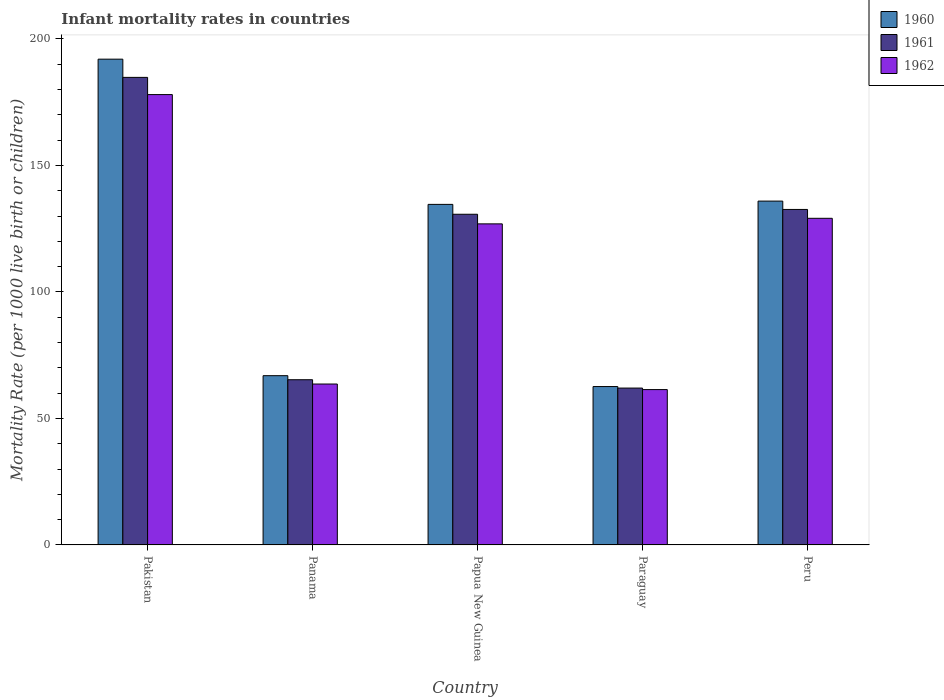How many different coloured bars are there?
Provide a succinct answer. 3. How many groups of bars are there?
Your answer should be very brief. 5. Are the number of bars per tick equal to the number of legend labels?
Your answer should be compact. Yes. Are the number of bars on each tick of the X-axis equal?
Keep it short and to the point. Yes. What is the label of the 3rd group of bars from the left?
Give a very brief answer. Papua New Guinea. What is the infant mortality rate in 1962 in Paraguay?
Your response must be concise. 61.4. Across all countries, what is the maximum infant mortality rate in 1962?
Your response must be concise. 178. Across all countries, what is the minimum infant mortality rate in 1960?
Make the answer very short. 62.6. In which country was the infant mortality rate in 1962 minimum?
Ensure brevity in your answer.  Paraguay. What is the total infant mortality rate in 1961 in the graph?
Offer a terse response. 575.4. What is the difference between the infant mortality rate in 1962 in Pakistan and that in Peru?
Your answer should be compact. 48.9. What is the difference between the infant mortality rate in 1961 in Paraguay and the infant mortality rate in 1962 in Pakistan?
Offer a very short reply. -116. What is the average infant mortality rate in 1962 per country?
Your response must be concise. 111.8. What is the difference between the infant mortality rate of/in 1960 and infant mortality rate of/in 1961 in Pakistan?
Give a very brief answer. 7.2. What is the ratio of the infant mortality rate in 1961 in Papua New Guinea to that in Paraguay?
Your response must be concise. 2.11. Is the infant mortality rate in 1962 in Panama less than that in Papua New Guinea?
Provide a succinct answer. Yes. What is the difference between the highest and the second highest infant mortality rate in 1961?
Your answer should be compact. 54.1. What is the difference between the highest and the lowest infant mortality rate in 1962?
Your answer should be very brief. 116.6. Is the sum of the infant mortality rate in 1961 in Panama and Papua New Guinea greater than the maximum infant mortality rate in 1960 across all countries?
Your answer should be compact. Yes. Does the graph contain grids?
Provide a succinct answer. No. Where does the legend appear in the graph?
Offer a very short reply. Top right. How many legend labels are there?
Make the answer very short. 3. How are the legend labels stacked?
Your response must be concise. Vertical. What is the title of the graph?
Offer a terse response. Infant mortality rates in countries. What is the label or title of the Y-axis?
Offer a very short reply. Mortality Rate (per 1000 live birth or children). What is the Mortality Rate (per 1000 live birth or children) in 1960 in Pakistan?
Offer a very short reply. 192. What is the Mortality Rate (per 1000 live birth or children) in 1961 in Pakistan?
Ensure brevity in your answer.  184.8. What is the Mortality Rate (per 1000 live birth or children) of 1962 in Pakistan?
Offer a very short reply. 178. What is the Mortality Rate (per 1000 live birth or children) in 1960 in Panama?
Your answer should be very brief. 66.9. What is the Mortality Rate (per 1000 live birth or children) of 1961 in Panama?
Provide a short and direct response. 65.3. What is the Mortality Rate (per 1000 live birth or children) of 1962 in Panama?
Give a very brief answer. 63.6. What is the Mortality Rate (per 1000 live birth or children) in 1960 in Papua New Guinea?
Your answer should be very brief. 134.6. What is the Mortality Rate (per 1000 live birth or children) in 1961 in Papua New Guinea?
Your response must be concise. 130.7. What is the Mortality Rate (per 1000 live birth or children) in 1962 in Papua New Guinea?
Keep it short and to the point. 126.9. What is the Mortality Rate (per 1000 live birth or children) in 1960 in Paraguay?
Ensure brevity in your answer.  62.6. What is the Mortality Rate (per 1000 live birth or children) in 1961 in Paraguay?
Your response must be concise. 62. What is the Mortality Rate (per 1000 live birth or children) of 1962 in Paraguay?
Offer a terse response. 61.4. What is the Mortality Rate (per 1000 live birth or children) of 1960 in Peru?
Offer a very short reply. 135.9. What is the Mortality Rate (per 1000 live birth or children) of 1961 in Peru?
Provide a succinct answer. 132.6. What is the Mortality Rate (per 1000 live birth or children) in 1962 in Peru?
Your answer should be compact. 129.1. Across all countries, what is the maximum Mortality Rate (per 1000 live birth or children) in 1960?
Make the answer very short. 192. Across all countries, what is the maximum Mortality Rate (per 1000 live birth or children) in 1961?
Ensure brevity in your answer.  184.8. Across all countries, what is the maximum Mortality Rate (per 1000 live birth or children) of 1962?
Keep it short and to the point. 178. Across all countries, what is the minimum Mortality Rate (per 1000 live birth or children) of 1960?
Your response must be concise. 62.6. Across all countries, what is the minimum Mortality Rate (per 1000 live birth or children) of 1961?
Your answer should be compact. 62. Across all countries, what is the minimum Mortality Rate (per 1000 live birth or children) in 1962?
Offer a terse response. 61.4. What is the total Mortality Rate (per 1000 live birth or children) in 1960 in the graph?
Ensure brevity in your answer.  592. What is the total Mortality Rate (per 1000 live birth or children) of 1961 in the graph?
Offer a very short reply. 575.4. What is the total Mortality Rate (per 1000 live birth or children) of 1962 in the graph?
Offer a terse response. 559. What is the difference between the Mortality Rate (per 1000 live birth or children) of 1960 in Pakistan and that in Panama?
Offer a very short reply. 125.1. What is the difference between the Mortality Rate (per 1000 live birth or children) in 1961 in Pakistan and that in Panama?
Ensure brevity in your answer.  119.5. What is the difference between the Mortality Rate (per 1000 live birth or children) of 1962 in Pakistan and that in Panama?
Your answer should be compact. 114.4. What is the difference between the Mortality Rate (per 1000 live birth or children) of 1960 in Pakistan and that in Papua New Guinea?
Make the answer very short. 57.4. What is the difference between the Mortality Rate (per 1000 live birth or children) in 1961 in Pakistan and that in Papua New Guinea?
Your answer should be very brief. 54.1. What is the difference between the Mortality Rate (per 1000 live birth or children) of 1962 in Pakistan and that in Papua New Guinea?
Offer a terse response. 51.1. What is the difference between the Mortality Rate (per 1000 live birth or children) of 1960 in Pakistan and that in Paraguay?
Ensure brevity in your answer.  129.4. What is the difference between the Mortality Rate (per 1000 live birth or children) in 1961 in Pakistan and that in Paraguay?
Keep it short and to the point. 122.8. What is the difference between the Mortality Rate (per 1000 live birth or children) in 1962 in Pakistan and that in Paraguay?
Your answer should be very brief. 116.6. What is the difference between the Mortality Rate (per 1000 live birth or children) of 1960 in Pakistan and that in Peru?
Give a very brief answer. 56.1. What is the difference between the Mortality Rate (per 1000 live birth or children) of 1961 in Pakistan and that in Peru?
Your answer should be very brief. 52.2. What is the difference between the Mortality Rate (per 1000 live birth or children) in 1962 in Pakistan and that in Peru?
Ensure brevity in your answer.  48.9. What is the difference between the Mortality Rate (per 1000 live birth or children) in 1960 in Panama and that in Papua New Guinea?
Offer a terse response. -67.7. What is the difference between the Mortality Rate (per 1000 live birth or children) in 1961 in Panama and that in Papua New Guinea?
Keep it short and to the point. -65.4. What is the difference between the Mortality Rate (per 1000 live birth or children) in 1962 in Panama and that in Papua New Guinea?
Provide a short and direct response. -63.3. What is the difference between the Mortality Rate (per 1000 live birth or children) in 1960 in Panama and that in Paraguay?
Your response must be concise. 4.3. What is the difference between the Mortality Rate (per 1000 live birth or children) of 1960 in Panama and that in Peru?
Ensure brevity in your answer.  -69. What is the difference between the Mortality Rate (per 1000 live birth or children) of 1961 in Panama and that in Peru?
Keep it short and to the point. -67.3. What is the difference between the Mortality Rate (per 1000 live birth or children) of 1962 in Panama and that in Peru?
Offer a very short reply. -65.5. What is the difference between the Mortality Rate (per 1000 live birth or children) of 1960 in Papua New Guinea and that in Paraguay?
Offer a terse response. 72. What is the difference between the Mortality Rate (per 1000 live birth or children) in 1961 in Papua New Guinea and that in Paraguay?
Make the answer very short. 68.7. What is the difference between the Mortality Rate (per 1000 live birth or children) of 1962 in Papua New Guinea and that in Paraguay?
Give a very brief answer. 65.5. What is the difference between the Mortality Rate (per 1000 live birth or children) of 1962 in Papua New Guinea and that in Peru?
Keep it short and to the point. -2.2. What is the difference between the Mortality Rate (per 1000 live birth or children) of 1960 in Paraguay and that in Peru?
Provide a short and direct response. -73.3. What is the difference between the Mortality Rate (per 1000 live birth or children) of 1961 in Paraguay and that in Peru?
Your response must be concise. -70.6. What is the difference between the Mortality Rate (per 1000 live birth or children) in 1962 in Paraguay and that in Peru?
Give a very brief answer. -67.7. What is the difference between the Mortality Rate (per 1000 live birth or children) in 1960 in Pakistan and the Mortality Rate (per 1000 live birth or children) in 1961 in Panama?
Provide a succinct answer. 126.7. What is the difference between the Mortality Rate (per 1000 live birth or children) of 1960 in Pakistan and the Mortality Rate (per 1000 live birth or children) of 1962 in Panama?
Make the answer very short. 128.4. What is the difference between the Mortality Rate (per 1000 live birth or children) of 1961 in Pakistan and the Mortality Rate (per 1000 live birth or children) of 1962 in Panama?
Your response must be concise. 121.2. What is the difference between the Mortality Rate (per 1000 live birth or children) of 1960 in Pakistan and the Mortality Rate (per 1000 live birth or children) of 1961 in Papua New Guinea?
Make the answer very short. 61.3. What is the difference between the Mortality Rate (per 1000 live birth or children) of 1960 in Pakistan and the Mortality Rate (per 1000 live birth or children) of 1962 in Papua New Guinea?
Give a very brief answer. 65.1. What is the difference between the Mortality Rate (per 1000 live birth or children) in 1961 in Pakistan and the Mortality Rate (per 1000 live birth or children) in 1962 in Papua New Guinea?
Your answer should be compact. 57.9. What is the difference between the Mortality Rate (per 1000 live birth or children) in 1960 in Pakistan and the Mortality Rate (per 1000 live birth or children) in 1961 in Paraguay?
Your answer should be very brief. 130. What is the difference between the Mortality Rate (per 1000 live birth or children) in 1960 in Pakistan and the Mortality Rate (per 1000 live birth or children) in 1962 in Paraguay?
Provide a succinct answer. 130.6. What is the difference between the Mortality Rate (per 1000 live birth or children) of 1961 in Pakistan and the Mortality Rate (per 1000 live birth or children) of 1962 in Paraguay?
Your answer should be very brief. 123.4. What is the difference between the Mortality Rate (per 1000 live birth or children) of 1960 in Pakistan and the Mortality Rate (per 1000 live birth or children) of 1961 in Peru?
Provide a succinct answer. 59.4. What is the difference between the Mortality Rate (per 1000 live birth or children) in 1960 in Pakistan and the Mortality Rate (per 1000 live birth or children) in 1962 in Peru?
Your response must be concise. 62.9. What is the difference between the Mortality Rate (per 1000 live birth or children) of 1961 in Pakistan and the Mortality Rate (per 1000 live birth or children) of 1962 in Peru?
Provide a short and direct response. 55.7. What is the difference between the Mortality Rate (per 1000 live birth or children) in 1960 in Panama and the Mortality Rate (per 1000 live birth or children) in 1961 in Papua New Guinea?
Ensure brevity in your answer.  -63.8. What is the difference between the Mortality Rate (per 1000 live birth or children) in 1960 in Panama and the Mortality Rate (per 1000 live birth or children) in 1962 in Papua New Guinea?
Offer a terse response. -60. What is the difference between the Mortality Rate (per 1000 live birth or children) in 1961 in Panama and the Mortality Rate (per 1000 live birth or children) in 1962 in Papua New Guinea?
Make the answer very short. -61.6. What is the difference between the Mortality Rate (per 1000 live birth or children) in 1961 in Panama and the Mortality Rate (per 1000 live birth or children) in 1962 in Paraguay?
Make the answer very short. 3.9. What is the difference between the Mortality Rate (per 1000 live birth or children) in 1960 in Panama and the Mortality Rate (per 1000 live birth or children) in 1961 in Peru?
Your answer should be compact. -65.7. What is the difference between the Mortality Rate (per 1000 live birth or children) of 1960 in Panama and the Mortality Rate (per 1000 live birth or children) of 1962 in Peru?
Your answer should be compact. -62.2. What is the difference between the Mortality Rate (per 1000 live birth or children) of 1961 in Panama and the Mortality Rate (per 1000 live birth or children) of 1962 in Peru?
Your answer should be very brief. -63.8. What is the difference between the Mortality Rate (per 1000 live birth or children) of 1960 in Papua New Guinea and the Mortality Rate (per 1000 live birth or children) of 1961 in Paraguay?
Offer a very short reply. 72.6. What is the difference between the Mortality Rate (per 1000 live birth or children) in 1960 in Papua New Guinea and the Mortality Rate (per 1000 live birth or children) in 1962 in Paraguay?
Offer a terse response. 73.2. What is the difference between the Mortality Rate (per 1000 live birth or children) of 1961 in Papua New Guinea and the Mortality Rate (per 1000 live birth or children) of 1962 in Paraguay?
Your response must be concise. 69.3. What is the difference between the Mortality Rate (per 1000 live birth or children) in 1960 in Papua New Guinea and the Mortality Rate (per 1000 live birth or children) in 1961 in Peru?
Your answer should be compact. 2. What is the difference between the Mortality Rate (per 1000 live birth or children) of 1961 in Papua New Guinea and the Mortality Rate (per 1000 live birth or children) of 1962 in Peru?
Ensure brevity in your answer.  1.6. What is the difference between the Mortality Rate (per 1000 live birth or children) in 1960 in Paraguay and the Mortality Rate (per 1000 live birth or children) in 1961 in Peru?
Make the answer very short. -70. What is the difference between the Mortality Rate (per 1000 live birth or children) in 1960 in Paraguay and the Mortality Rate (per 1000 live birth or children) in 1962 in Peru?
Provide a short and direct response. -66.5. What is the difference between the Mortality Rate (per 1000 live birth or children) of 1961 in Paraguay and the Mortality Rate (per 1000 live birth or children) of 1962 in Peru?
Offer a terse response. -67.1. What is the average Mortality Rate (per 1000 live birth or children) of 1960 per country?
Your answer should be very brief. 118.4. What is the average Mortality Rate (per 1000 live birth or children) of 1961 per country?
Provide a short and direct response. 115.08. What is the average Mortality Rate (per 1000 live birth or children) in 1962 per country?
Make the answer very short. 111.8. What is the difference between the Mortality Rate (per 1000 live birth or children) in 1960 and Mortality Rate (per 1000 live birth or children) in 1962 in Papua New Guinea?
Provide a succinct answer. 7.7. What is the difference between the Mortality Rate (per 1000 live birth or children) in 1961 and Mortality Rate (per 1000 live birth or children) in 1962 in Papua New Guinea?
Give a very brief answer. 3.8. What is the difference between the Mortality Rate (per 1000 live birth or children) of 1960 and Mortality Rate (per 1000 live birth or children) of 1962 in Peru?
Provide a short and direct response. 6.8. What is the ratio of the Mortality Rate (per 1000 live birth or children) of 1960 in Pakistan to that in Panama?
Offer a terse response. 2.87. What is the ratio of the Mortality Rate (per 1000 live birth or children) of 1961 in Pakistan to that in Panama?
Give a very brief answer. 2.83. What is the ratio of the Mortality Rate (per 1000 live birth or children) of 1962 in Pakistan to that in Panama?
Provide a short and direct response. 2.8. What is the ratio of the Mortality Rate (per 1000 live birth or children) in 1960 in Pakistan to that in Papua New Guinea?
Keep it short and to the point. 1.43. What is the ratio of the Mortality Rate (per 1000 live birth or children) of 1961 in Pakistan to that in Papua New Guinea?
Offer a terse response. 1.41. What is the ratio of the Mortality Rate (per 1000 live birth or children) of 1962 in Pakistan to that in Papua New Guinea?
Your response must be concise. 1.4. What is the ratio of the Mortality Rate (per 1000 live birth or children) of 1960 in Pakistan to that in Paraguay?
Ensure brevity in your answer.  3.07. What is the ratio of the Mortality Rate (per 1000 live birth or children) of 1961 in Pakistan to that in Paraguay?
Offer a terse response. 2.98. What is the ratio of the Mortality Rate (per 1000 live birth or children) of 1962 in Pakistan to that in Paraguay?
Provide a succinct answer. 2.9. What is the ratio of the Mortality Rate (per 1000 live birth or children) in 1960 in Pakistan to that in Peru?
Your answer should be very brief. 1.41. What is the ratio of the Mortality Rate (per 1000 live birth or children) of 1961 in Pakistan to that in Peru?
Offer a very short reply. 1.39. What is the ratio of the Mortality Rate (per 1000 live birth or children) of 1962 in Pakistan to that in Peru?
Your answer should be compact. 1.38. What is the ratio of the Mortality Rate (per 1000 live birth or children) of 1960 in Panama to that in Papua New Guinea?
Provide a short and direct response. 0.5. What is the ratio of the Mortality Rate (per 1000 live birth or children) in 1961 in Panama to that in Papua New Guinea?
Your response must be concise. 0.5. What is the ratio of the Mortality Rate (per 1000 live birth or children) in 1962 in Panama to that in Papua New Guinea?
Your response must be concise. 0.5. What is the ratio of the Mortality Rate (per 1000 live birth or children) in 1960 in Panama to that in Paraguay?
Provide a succinct answer. 1.07. What is the ratio of the Mortality Rate (per 1000 live birth or children) of 1961 in Panama to that in Paraguay?
Ensure brevity in your answer.  1.05. What is the ratio of the Mortality Rate (per 1000 live birth or children) in 1962 in Panama to that in Paraguay?
Offer a terse response. 1.04. What is the ratio of the Mortality Rate (per 1000 live birth or children) in 1960 in Panama to that in Peru?
Your answer should be compact. 0.49. What is the ratio of the Mortality Rate (per 1000 live birth or children) of 1961 in Panama to that in Peru?
Offer a very short reply. 0.49. What is the ratio of the Mortality Rate (per 1000 live birth or children) of 1962 in Panama to that in Peru?
Provide a short and direct response. 0.49. What is the ratio of the Mortality Rate (per 1000 live birth or children) of 1960 in Papua New Guinea to that in Paraguay?
Give a very brief answer. 2.15. What is the ratio of the Mortality Rate (per 1000 live birth or children) of 1961 in Papua New Guinea to that in Paraguay?
Make the answer very short. 2.11. What is the ratio of the Mortality Rate (per 1000 live birth or children) in 1962 in Papua New Guinea to that in Paraguay?
Keep it short and to the point. 2.07. What is the ratio of the Mortality Rate (per 1000 live birth or children) of 1961 in Papua New Guinea to that in Peru?
Make the answer very short. 0.99. What is the ratio of the Mortality Rate (per 1000 live birth or children) of 1962 in Papua New Guinea to that in Peru?
Give a very brief answer. 0.98. What is the ratio of the Mortality Rate (per 1000 live birth or children) of 1960 in Paraguay to that in Peru?
Provide a short and direct response. 0.46. What is the ratio of the Mortality Rate (per 1000 live birth or children) of 1961 in Paraguay to that in Peru?
Your answer should be compact. 0.47. What is the ratio of the Mortality Rate (per 1000 live birth or children) in 1962 in Paraguay to that in Peru?
Give a very brief answer. 0.48. What is the difference between the highest and the second highest Mortality Rate (per 1000 live birth or children) of 1960?
Your answer should be compact. 56.1. What is the difference between the highest and the second highest Mortality Rate (per 1000 live birth or children) of 1961?
Provide a short and direct response. 52.2. What is the difference between the highest and the second highest Mortality Rate (per 1000 live birth or children) in 1962?
Your response must be concise. 48.9. What is the difference between the highest and the lowest Mortality Rate (per 1000 live birth or children) in 1960?
Offer a very short reply. 129.4. What is the difference between the highest and the lowest Mortality Rate (per 1000 live birth or children) of 1961?
Ensure brevity in your answer.  122.8. What is the difference between the highest and the lowest Mortality Rate (per 1000 live birth or children) in 1962?
Keep it short and to the point. 116.6. 